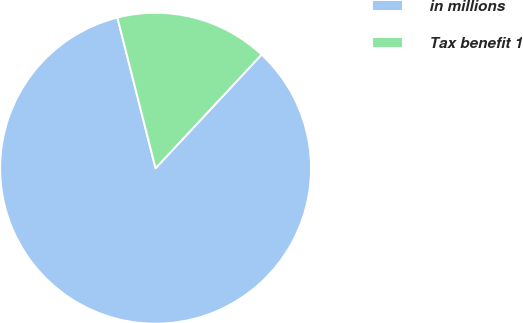Convert chart. <chart><loc_0><loc_0><loc_500><loc_500><pie_chart><fcel>in millions<fcel>Tax benefit 1<nl><fcel>84.11%<fcel>15.89%<nl></chart> 